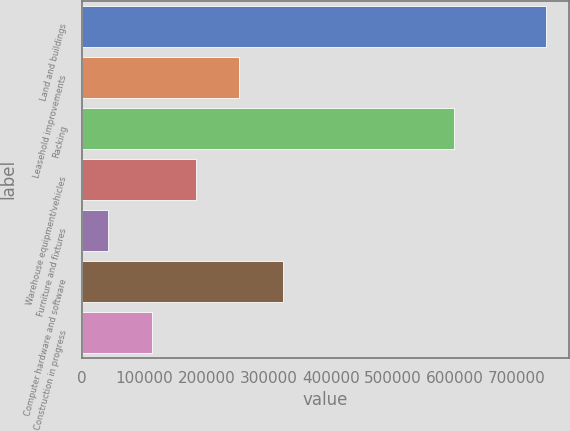<chart> <loc_0><loc_0><loc_500><loc_500><bar_chart><fcel>Land and buildings<fcel>Leasehold improvements<fcel>Racking<fcel>Warehouse equipment/vehicles<fcel>Furniture and fixtures<fcel>Computer hardware and software<fcel>Construction in progress<nl><fcel>745838<fcel>253149<fcel>598101<fcel>182764<fcel>41996<fcel>323533<fcel>112380<nl></chart> 